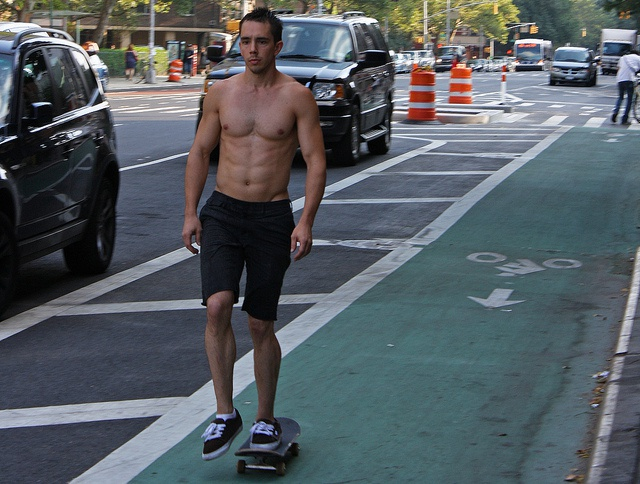Describe the objects in this image and their specific colors. I can see people in black, gray, brown, and maroon tones, car in black, gray, white, and darkgray tones, truck in black, gray, white, and darkgray tones, truck in black, gray, and darkgray tones, and skateboard in black, gray, and darkblue tones in this image. 